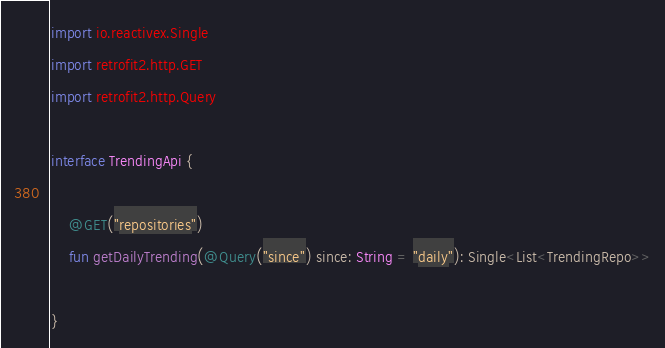Convert code to text. <code><loc_0><loc_0><loc_500><loc_500><_Kotlin_>import io.reactivex.Single
import retrofit2.http.GET
import retrofit2.http.Query

interface TrendingApi {

    @GET("repositories")
    fun getDailyTrending(@Query("since") since: String = "daily"): Single<List<TrendingRepo>>

}</code> 